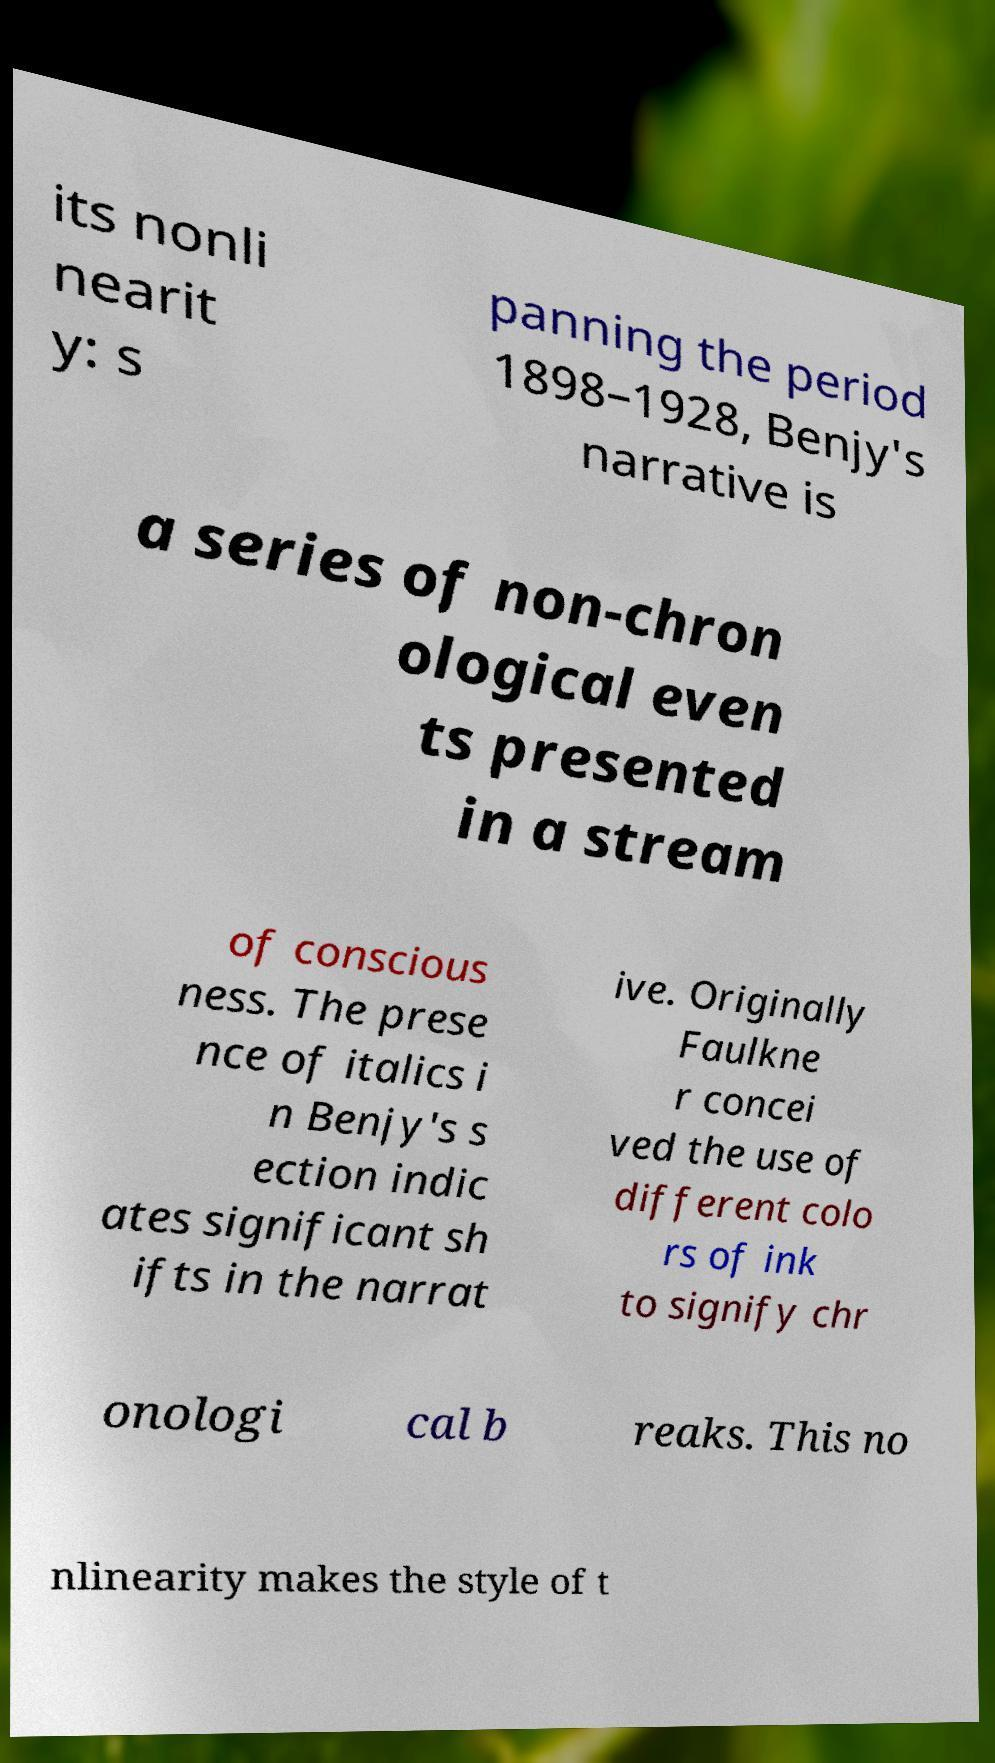There's text embedded in this image that I need extracted. Can you transcribe it verbatim? its nonli nearit y: s panning the period 1898–1928, Benjy's narrative is a series of non-chron ological even ts presented in a stream of conscious ness. The prese nce of italics i n Benjy's s ection indic ates significant sh ifts in the narrat ive. Originally Faulkne r concei ved the use of different colo rs of ink to signify chr onologi cal b reaks. This no nlinearity makes the style of t 